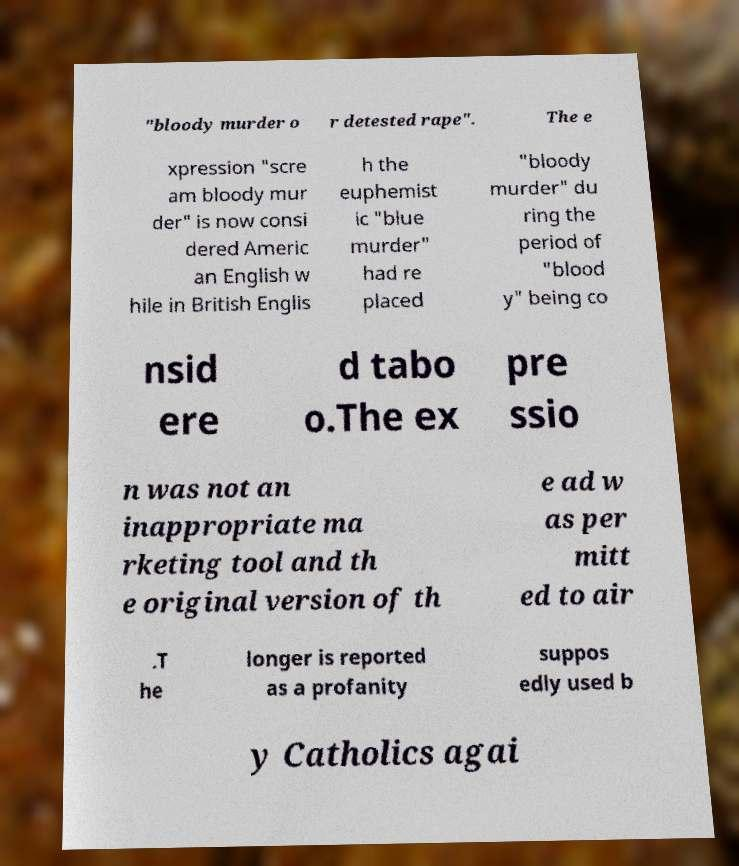Could you extract and type out the text from this image? "bloody murder o r detested rape". The e xpression "scre am bloody mur der" is now consi dered Americ an English w hile in British Englis h the euphemist ic "blue murder" had re placed "bloody murder" du ring the period of "blood y" being co nsid ere d tabo o.The ex pre ssio n was not an inappropriate ma rketing tool and th e original version of th e ad w as per mitt ed to air .T he longer is reported as a profanity suppos edly used b y Catholics agai 